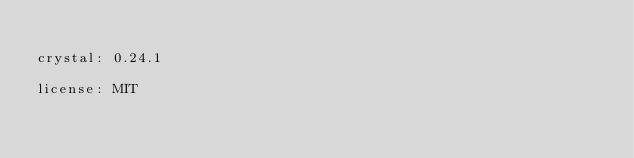<code> <loc_0><loc_0><loc_500><loc_500><_YAML_>
crystal: 0.24.1

license: MIT
</code> 